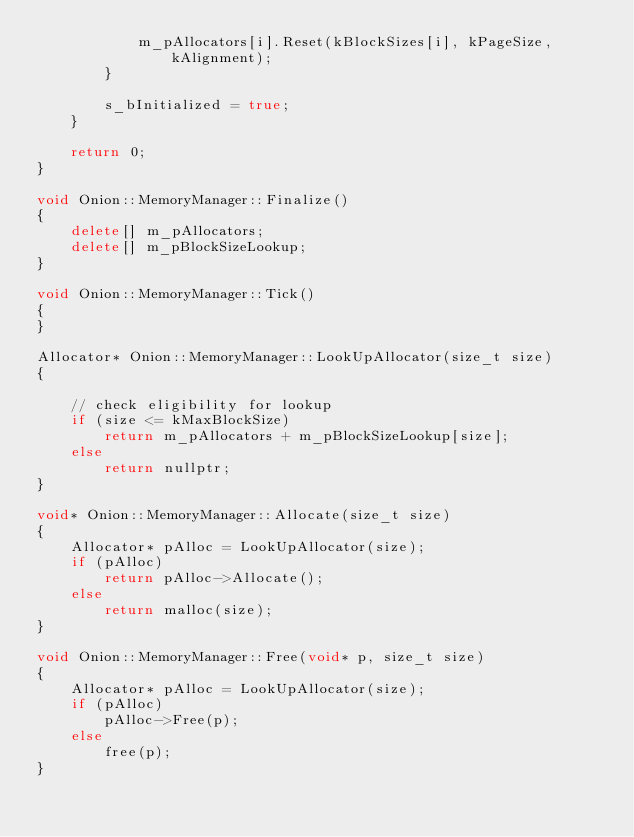<code> <loc_0><loc_0><loc_500><loc_500><_C++_>            m_pAllocators[i].Reset(kBlockSizes[i], kPageSize, kAlignment);
        }

        s_bInitialized = true;
    }

    return 0;
}

void Onion::MemoryManager::Finalize()
{
    delete[] m_pAllocators;
    delete[] m_pBlockSizeLookup;
}

void Onion::MemoryManager::Tick()
{
}

Allocator* Onion::MemoryManager::LookUpAllocator(size_t size)
{

    // check eligibility for lookup
    if (size <= kMaxBlockSize)
        return m_pAllocators + m_pBlockSizeLookup[size];
    else
        return nullptr;
}

void* Onion::MemoryManager::Allocate(size_t size)
{
    Allocator* pAlloc = LookUpAllocator(size);
    if (pAlloc)
        return pAlloc->Allocate();
    else
        return malloc(size);
}

void Onion::MemoryManager::Free(void* p, size_t size)
{
    Allocator* pAlloc = LookUpAllocator(size);
    if (pAlloc)
        pAlloc->Free(p);
    else
        free(p);
}</code> 